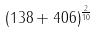Convert formula to latex. <formula><loc_0><loc_0><loc_500><loc_500>( 1 3 8 + 4 0 6 ) ^ { \frac { 2 } { 1 0 } }</formula> 